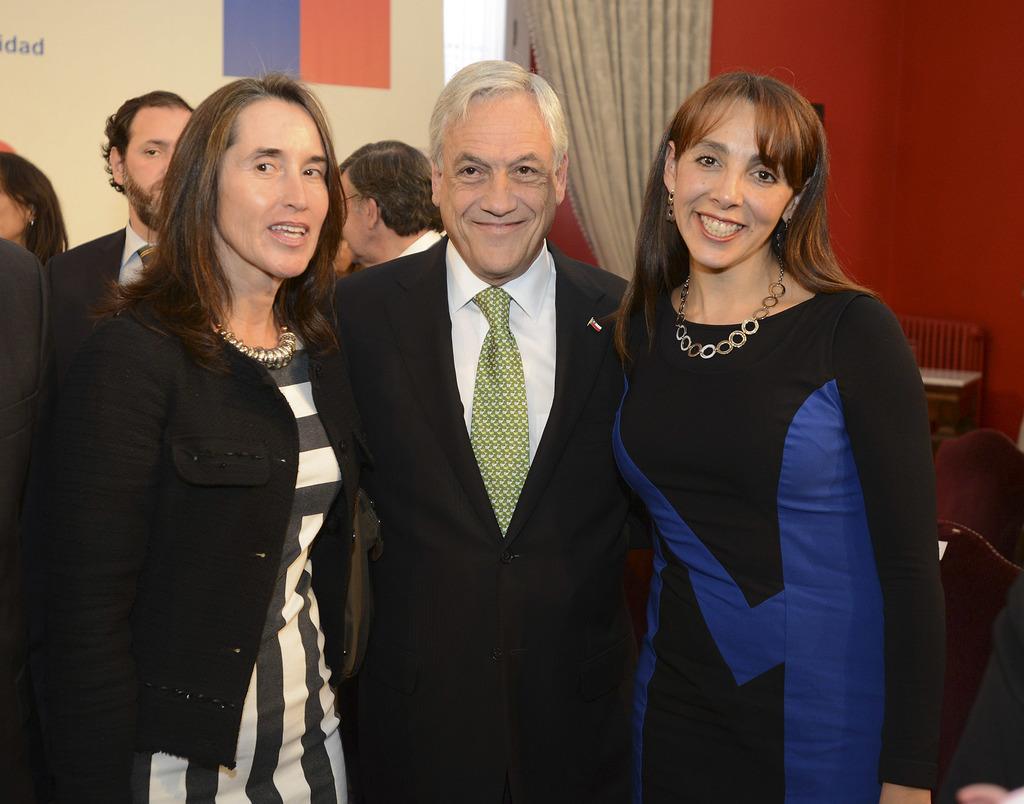Describe this image in one or two sentences. Int his image in the foreground there are three persons standing and smiling, and in the background there are some persons, curtain, board, wall and bench. 